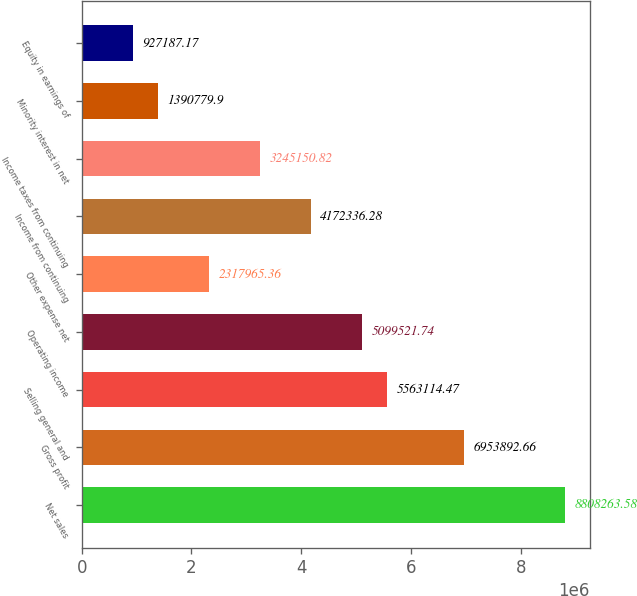Convert chart. <chart><loc_0><loc_0><loc_500><loc_500><bar_chart><fcel>Net sales<fcel>Gross profit<fcel>Selling general and<fcel>Operating income<fcel>Other expense net<fcel>Income from continuing<fcel>Income taxes from continuing<fcel>Minority interest in net<fcel>Equity in earnings of<nl><fcel>8.80826e+06<fcel>6.95389e+06<fcel>5.56311e+06<fcel>5.09952e+06<fcel>2.31797e+06<fcel>4.17234e+06<fcel>3.24515e+06<fcel>1.39078e+06<fcel>927187<nl></chart> 